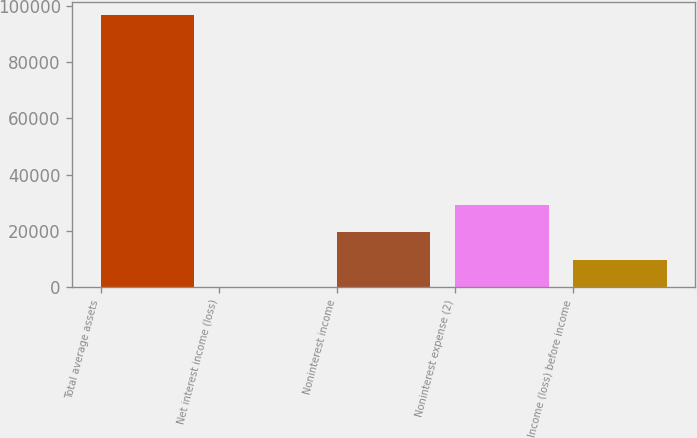Convert chart. <chart><loc_0><loc_0><loc_500><loc_500><bar_chart><fcel>Total average assets<fcel>Net interest income (loss)<fcel>Noninterest income<fcel>Noninterest expense (2)<fcel>Income (loss) before income<nl><fcel>96732<fcel>42<fcel>19380<fcel>29049<fcel>9711<nl></chart> 